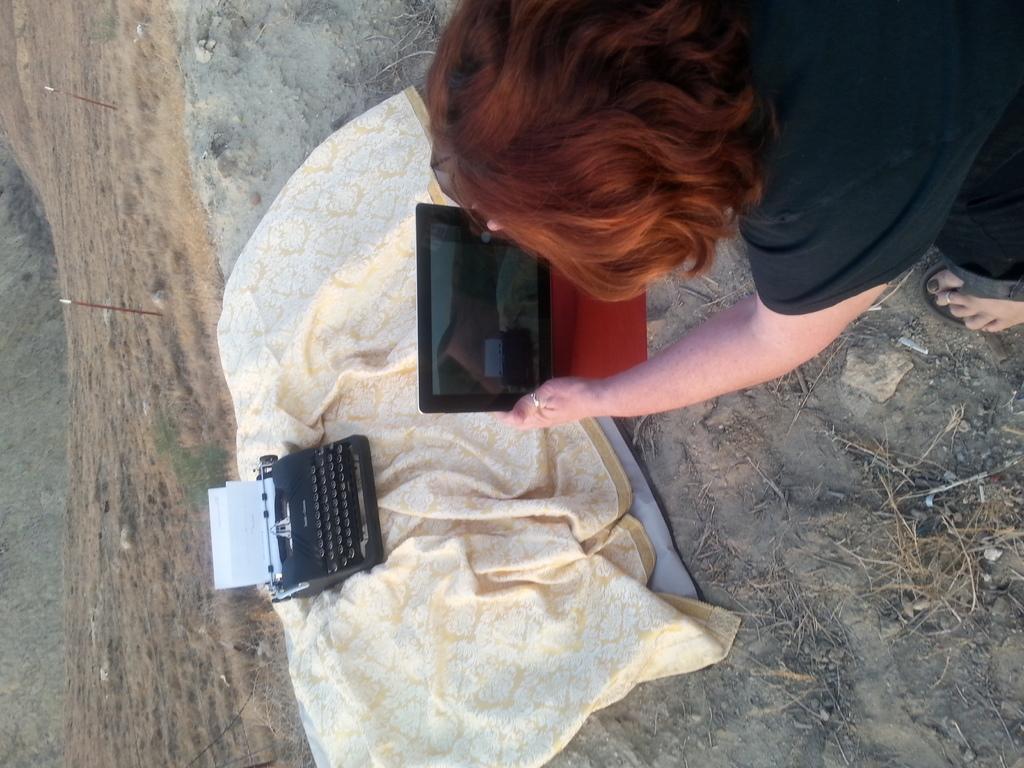Please provide a concise description of this image. In the picture we can see a person holding a tablet and capturing the picture of the typewriter which is on the cloth and behind it we can see the muddy surface. 